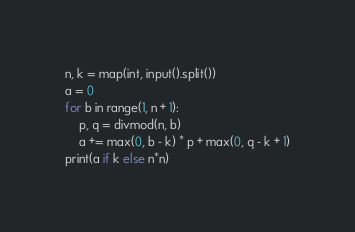<code> <loc_0><loc_0><loc_500><loc_500><_Python_>n, k = map(int, input().split())
a = 0
for b in range(1, n + 1):
    p, q = divmod(n, b)
    a += max(0, b - k) * p + max(0, q - k + 1)
print(a if k else n*n)</code> 